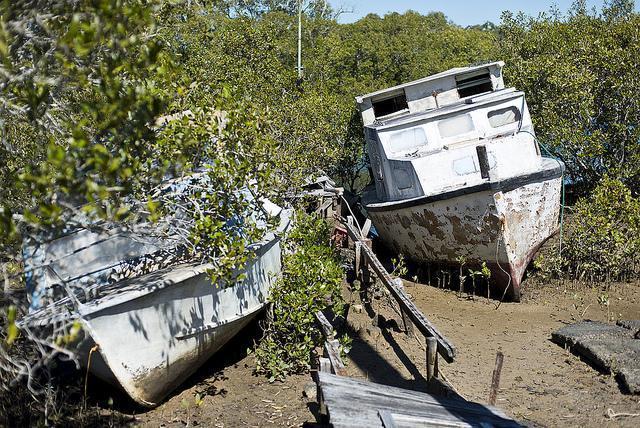How many boats do you see?
Give a very brief answer. 2. How many boats are visible?
Give a very brief answer. 2. How many shirtless people do you see ?
Give a very brief answer. 0. 